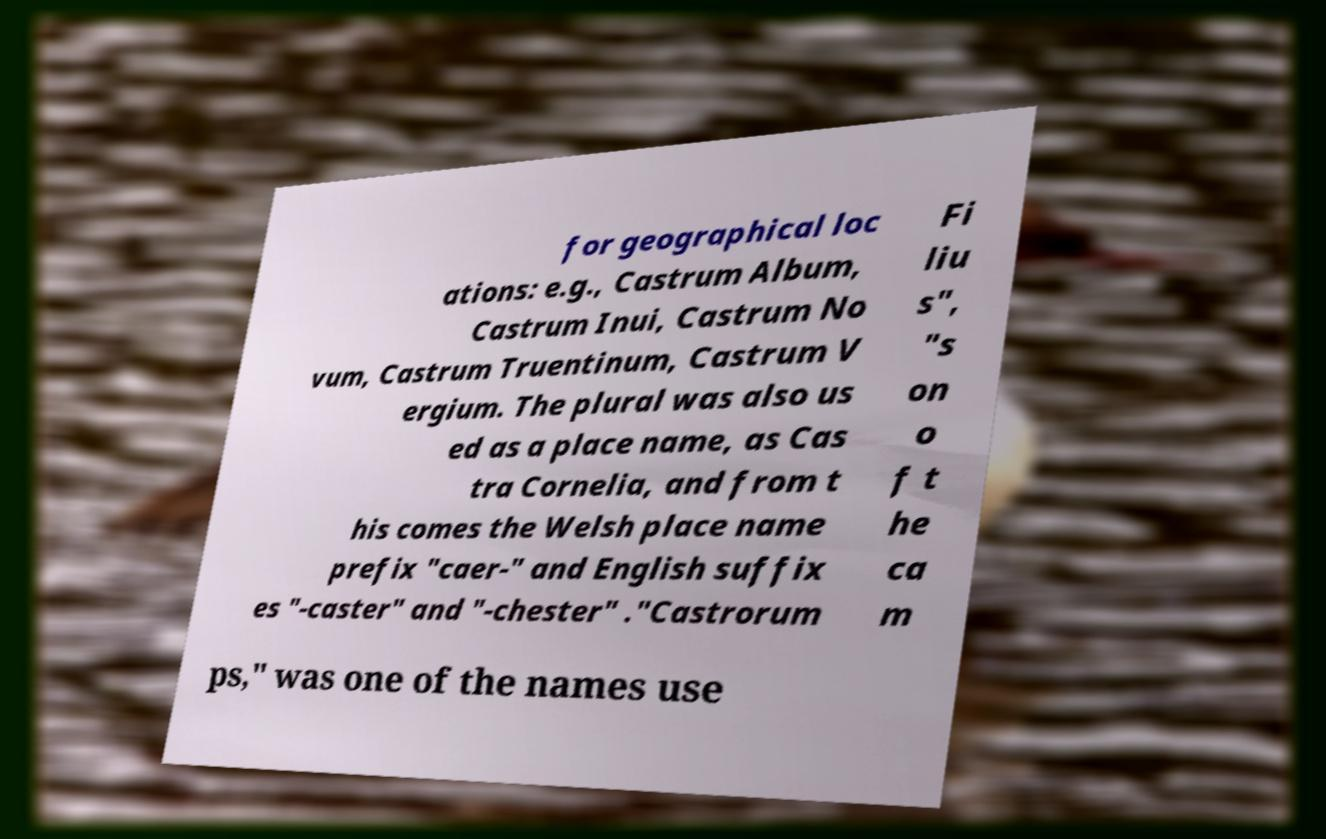Could you extract and type out the text from this image? for geographical loc ations: e.g., Castrum Album, Castrum Inui, Castrum No vum, Castrum Truentinum, Castrum V ergium. The plural was also us ed as a place name, as Cas tra Cornelia, and from t his comes the Welsh place name prefix "caer-" and English suffix es "-caster" and "-chester" ."Castrorum Fi liu s", "s on o f t he ca m ps," was one of the names use 